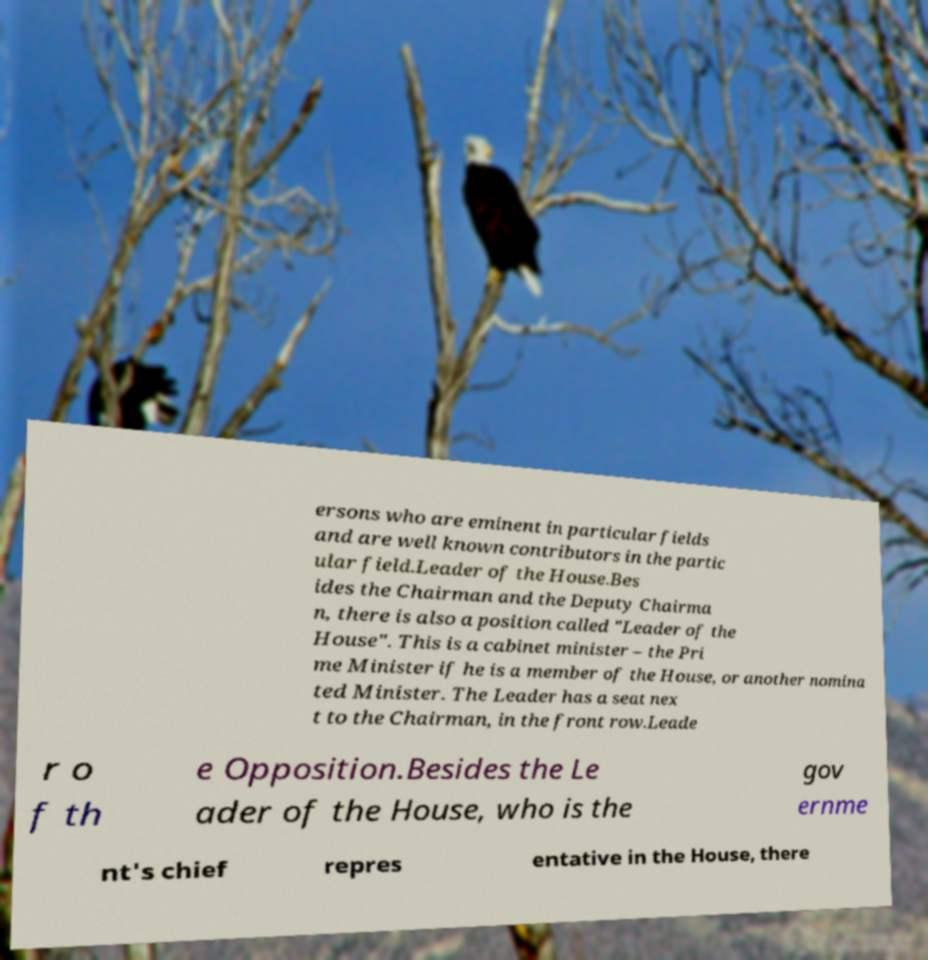Could you assist in decoding the text presented in this image and type it out clearly? ersons who are eminent in particular fields and are well known contributors in the partic ular field.Leader of the House.Bes ides the Chairman and the Deputy Chairma n, there is also a position called "Leader of the House". This is a cabinet minister – the Pri me Minister if he is a member of the House, or another nomina ted Minister. The Leader has a seat nex t to the Chairman, in the front row.Leade r o f th e Opposition.Besides the Le ader of the House, who is the gov ernme nt's chief repres entative in the House, there 